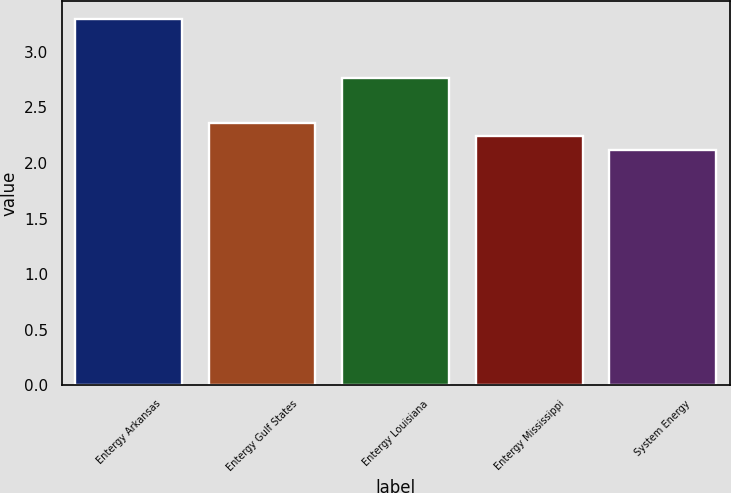<chart> <loc_0><loc_0><loc_500><loc_500><bar_chart><fcel>Entergy Arkansas<fcel>Entergy Gulf States<fcel>Entergy Louisiana<fcel>Entergy Mississippi<fcel>System Energy<nl><fcel>3.29<fcel>2.36<fcel>2.76<fcel>2.24<fcel>2.12<nl></chart> 